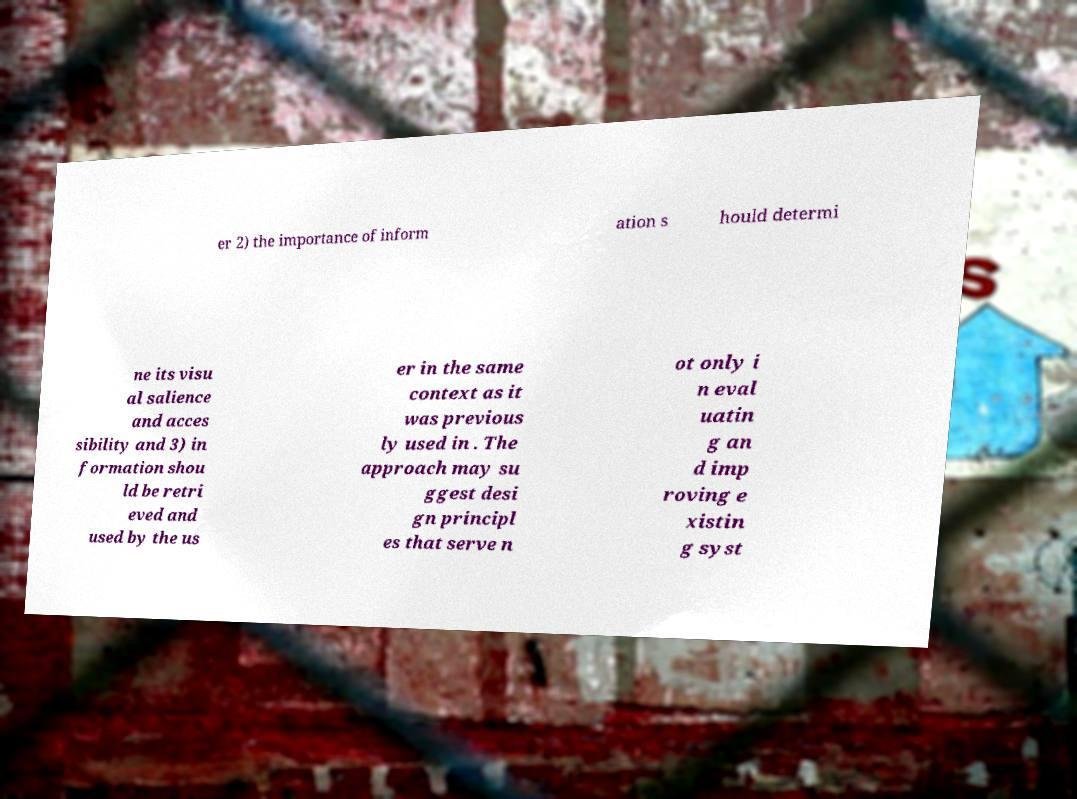What messages or text are displayed in this image? I need them in a readable, typed format. er 2) the importance of inform ation s hould determi ne its visu al salience and acces sibility and 3) in formation shou ld be retri eved and used by the us er in the same context as it was previous ly used in . The approach may su ggest desi gn principl es that serve n ot only i n eval uatin g an d imp roving e xistin g syst 